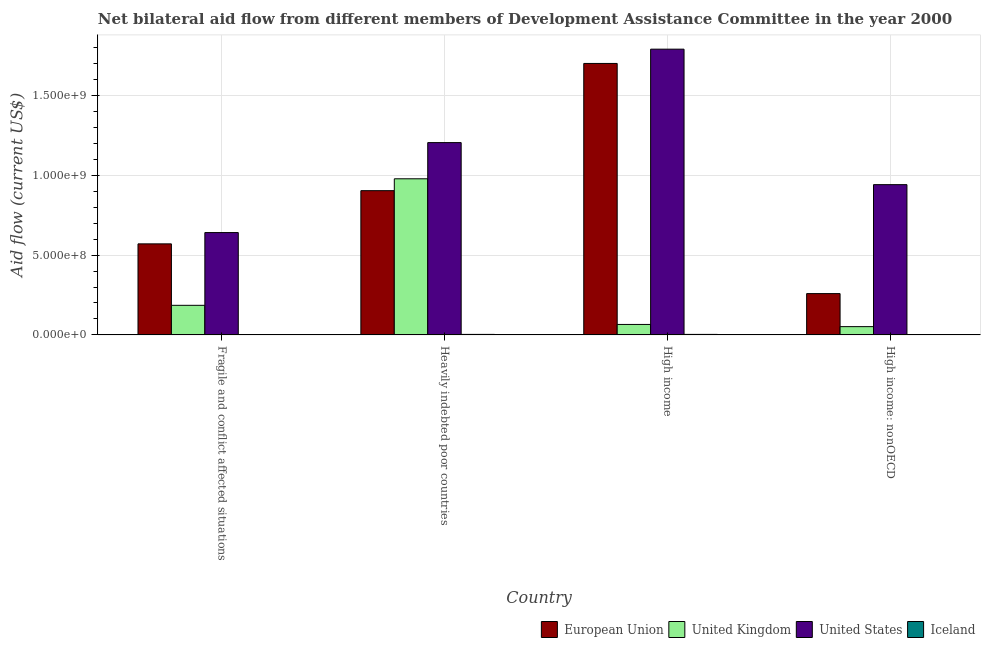How many different coloured bars are there?
Your answer should be compact. 4. Are the number of bars on each tick of the X-axis equal?
Your answer should be compact. Yes. How many bars are there on the 2nd tick from the right?
Make the answer very short. 4. What is the label of the 2nd group of bars from the left?
Make the answer very short. Heavily indebted poor countries. What is the amount of aid given by uk in Fragile and conflict affected situations?
Your answer should be very brief. 1.85e+08. Across all countries, what is the maximum amount of aid given by eu?
Offer a very short reply. 1.70e+09. Across all countries, what is the minimum amount of aid given by us?
Your answer should be very brief. 6.41e+08. In which country was the amount of aid given by us maximum?
Your answer should be compact. High income. In which country was the amount of aid given by iceland minimum?
Give a very brief answer. Fragile and conflict affected situations. What is the total amount of aid given by us in the graph?
Your answer should be very brief. 4.58e+09. What is the difference between the amount of aid given by us in Fragile and conflict affected situations and that in High income?
Keep it short and to the point. -1.15e+09. What is the difference between the amount of aid given by uk in Heavily indebted poor countries and the amount of aid given by us in Fragile and conflict affected situations?
Offer a terse response. 3.37e+08. What is the average amount of aid given by eu per country?
Provide a short and direct response. 8.59e+08. What is the difference between the amount of aid given by uk and amount of aid given by eu in Fragile and conflict affected situations?
Give a very brief answer. -3.85e+08. In how many countries, is the amount of aid given by eu greater than 1400000000 US$?
Offer a very short reply. 1. What is the ratio of the amount of aid given by uk in Fragile and conflict affected situations to that in High income: nonOECD?
Offer a terse response. 3.58. Is the difference between the amount of aid given by us in Fragile and conflict affected situations and Heavily indebted poor countries greater than the difference between the amount of aid given by eu in Fragile and conflict affected situations and Heavily indebted poor countries?
Provide a succinct answer. No. What is the difference between the highest and the second highest amount of aid given by eu?
Your response must be concise. 7.97e+08. What is the difference between the highest and the lowest amount of aid given by uk?
Your answer should be compact. 9.26e+08. In how many countries, is the amount of aid given by us greater than the average amount of aid given by us taken over all countries?
Provide a succinct answer. 2. Is the sum of the amount of aid given by iceland in Fragile and conflict affected situations and High income greater than the maximum amount of aid given by uk across all countries?
Provide a short and direct response. No. Is it the case that in every country, the sum of the amount of aid given by uk and amount of aid given by us is greater than the sum of amount of aid given by iceland and amount of aid given by eu?
Offer a very short reply. No. What does the 3rd bar from the right in High income: nonOECD represents?
Your answer should be very brief. United Kingdom. Is it the case that in every country, the sum of the amount of aid given by eu and amount of aid given by uk is greater than the amount of aid given by us?
Provide a short and direct response. No. How many bars are there?
Your answer should be very brief. 16. How many countries are there in the graph?
Make the answer very short. 4. Are the values on the major ticks of Y-axis written in scientific E-notation?
Offer a terse response. Yes. Does the graph contain any zero values?
Make the answer very short. No. Does the graph contain grids?
Your response must be concise. Yes. How many legend labels are there?
Your answer should be very brief. 4. What is the title of the graph?
Your answer should be compact. Net bilateral aid flow from different members of Development Assistance Committee in the year 2000. Does "Periodicity assessment" appear as one of the legend labels in the graph?
Your response must be concise. No. What is the label or title of the Y-axis?
Your answer should be very brief. Aid flow (current US$). What is the Aid flow (current US$) of European Union in Fragile and conflict affected situations?
Keep it short and to the point. 5.71e+08. What is the Aid flow (current US$) of United Kingdom in Fragile and conflict affected situations?
Provide a short and direct response. 1.85e+08. What is the Aid flow (current US$) of United States in Fragile and conflict affected situations?
Provide a succinct answer. 6.41e+08. What is the Aid flow (current US$) of Iceland in Fragile and conflict affected situations?
Offer a very short reply. 1.05e+06. What is the Aid flow (current US$) of European Union in Heavily indebted poor countries?
Your answer should be compact. 9.04e+08. What is the Aid flow (current US$) of United Kingdom in Heavily indebted poor countries?
Your answer should be very brief. 9.78e+08. What is the Aid flow (current US$) of United States in Heavily indebted poor countries?
Offer a very short reply. 1.21e+09. What is the Aid flow (current US$) in Iceland in Heavily indebted poor countries?
Give a very brief answer. 3.23e+06. What is the Aid flow (current US$) of European Union in High income?
Your response must be concise. 1.70e+09. What is the Aid flow (current US$) of United Kingdom in High income?
Ensure brevity in your answer.  6.56e+07. What is the Aid flow (current US$) in United States in High income?
Your answer should be compact. 1.79e+09. What is the Aid flow (current US$) in Iceland in High income?
Provide a short and direct response. 3.23e+06. What is the Aid flow (current US$) in European Union in High income: nonOECD?
Ensure brevity in your answer.  2.59e+08. What is the Aid flow (current US$) of United Kingdom in High income: nonOECD?
Your response must be concise. 5.18e+07. What is the Aid flow (current US$) of United States in High income: nonOECD?
Offer a very short reply. 9.42e+08. What is the Aid flow (current US$) in Iceland in High income: nonOECD?
Your answer should be very brief. 1.26e+06. Across all countries, what is the maximum Aid flow (current US$) in European Union?
Provide a short and direct response. 1.70e+09. Across all countries, what is the maximum Aid flow (current US$) of United Kingdom?
Offer a terse response. 9.78e+08. Across all countries, what is the maximum Aid flow (current US$) in United States?
Provide a short and direct response. 1.79e+09. Across all countries, what is the maximum Aid flow (current US$) of Iceland?
Ensure brevity in your answer.  3.23e+06. Across all countries, what is the minimum Aid flow (current US$) in European Union?
Offer a terse response. 2.59e+08. Across all countries, what is the minimum Aid flow (current US$) of United Kingdom?
Offer a terse response. 5.18e+07. Across all countries, what is the minimum Aid flow (current US$) of United States?
Offer a terse response. 6.41e+08. Across all countries, what is the minimum Aid flow (current US$) of Iceland?
Provide a succinct answer. 1.05e+06. What is the total Aid flow (current US$) of European Union in the graph?
Provide a succinct answer. 3.43e+09. What is the total Aid flow (current US$) of United Kingdom in the graph?
Offer a terse response. 1.28e+09. What is the total Aid flow (current US$) of United States in the graph?
Give a very brief answer. 4.58e+09. What is the total Aid flow (current US$) of Iceland in the graph?
Keep it short and to the point. 8.77e+06. What is the difference between the Aid flow (current US$) in European Union in Fragile and conflict affected situations and that in Heavily indebted poor countries?
Offer a very short reply. -3.33e+08. What is the difference between the Aid flow (current US$) in United Kingdom in Fragile and conflict affected situations and that in Heavily indebted poor countries?
Your answer should be very brief. -7.93e+08. What is the difference between the Aid flow (current US$) in United States in Fragile and conflict affected situations and that in Heavily indebted poor countries?
Provide a short and direct response. -5.64e+08. What is the difference between the Aid flow (current US$) in Iceland in Fragile and conflict affected situations and that in Heavily indebted poor countries?
Offer a terse response. -2.18e+06. What is the difference between the Aid flow (current US$) of European Union in Fragile and conflict affected situations and that in High income?
Give a very brief answer. -1.13e+09. What is the difference between the Aid flow (current US$) in United Kingdom in Fragile and conflict affected situations and that in High income?
Your answer should be very brief. 1.20e+08. What is the difference between the Aid flow (current US$) of United States in Fragile and conflict affected situations and that in High income?
Ensure brevity in your answer.  -1.15e+09. What is the difference between the Aid flow (current US$) of Iceland in Fragile and conflict affected situations and that in High income?
Provide a short and direct response. -2.18e+06. What is the difference between the Aid flow (current US$) of European Union in Fragile and conflict affected situations and that in High income: nonOECD?
Your answer should be very brief. 3.12e+08. What is the difference between the Aid flow (current US$) of United Kingdom in Fragile and conflict affected situations and that in High income: nonOECD?
Ensure brevity in your answer.  1.34e+08. What is the difference between the Aid flow (current US$) of United States in Fragile and conflict affected situations and that in High income: nonOECD?
Keep it short and to the point. -3.00e+08. What is the difference between the Aid flow (current US$) in European Union in Heavily indebted poor countries and that in High income?
Make the answer very short. -7.97e+08. What is the difference between the Aid flow (current US$) in United Kingdom in Heavily indebted poor countries and that in High income?
Provide a short and direct response. 9.13e+08. What is the difference between the Aid flow (current US$) of United States in Heavily indebted poor countries and that in High income?
Give a very brief answer. -5.86e+08. What is the difference between the Aid flow (current US$) of European Union in Heavily indebted poor countries and that in High income: nonOECD?
Give a very brief answer. 6.45e+08. What is the difference between the Aid flow (current US$) of United Kingdom in Heavily indebted poor countries and that in High income: nonOECD?
Ensure brevity in your answer.  9.26e+08. What is the difference between the Aid flow (current US$) of United States in Heavily indebted poor countries and that in High income: nonOECD?
Provide a short and direct response. 2.63e+08. What is the difference between the Aid flow (current US$) in Iceland in Heavily indebted poor countries and that in High income: nonOECD?
Keep it short and to the point. 1.97e+06. What is the difference between the Aid flow (current US$) in European Union in High income and that in High income: nonOECD?
Give a very brief answer. 1.44e+09. What is the difference between the Aid flow (current US$) of United Kingdom in High income and that in High income: nonOECD?
Your answer should be compact. 1.38e+07. What is the difference between the Aid flow (current US$) of United States in High income and that in High income: nonOECD?
Your answer should be compact. 8.49e+08. What is the difference between the Aid flow (current US$) in Iceland in High income and that in High income: nonOECD?
Offer a very short reply. 1.97e+06. What is the difference between the Aid flow (current US$) of European Union in Fragile and conflict affected situations and the Aid flow (current US$) of United Kingdom in Heavily indebted poor countries?
Ensure brevity in your answer.  -4.08e+08. What is the difference between the Aid flow (current US$) of European Union in Fragile and conflict affected situations and the Aid flow (current US$) of United States in Heavily indebted poor countries?
Ensure brevity in your answer.  -6.35e+08. What is the difference between the Aid flow (current US$) of European Union in Fragile and conflict affected situations and the Aid flow (current US$) of Iceland in Heavily indebted poor countries?
Provide a succinct answer. 5.67e+08. What is the difference between the Aid flow (current US$) in United Kingdom in Fragile and conflict affected situations and the Aid flow (current US$) in United States in Heavily indebted poor countries?
Provide a short and direct response. -1.02e+09. What is the difference between the Aid flow (current US$) in United Kingdom in Fragile and conflict affected situations and the Aid flow (current US$) in Iceland in Heavily indebted poor countries?
Make the answer very short. 1.82e+08. What is the difference between the Aid flow (current US$) in United States in Fragile and conflict affected situations and the Aid flow (current US$) in Iceland in Heavily indebted poor countries?
Provide a succinct answer. 6.38e+08. What is the difference between the Aid flow (current US$) of European Union in Fragile and conflict affected situations and the Aid flow (current US$) of United Kingdom in High income?
Provide a succinct answer. 5.05e+08. What is the difference between the Aid flow (current US$) of European Union in Fragile and conflict affected situations and the Aid flow (current US$) of United States in High income?
Keep it short and to the point. -1.22e+09. What is the difference between the Aid flow (current US$) in European Union in Fragile and conflict affected situations and the Aid flow (current US$) in Iceland in High income?
Give a very brief answer. 5.67e+08. What is the difference between the Aid flow (current US$) of United Kingdom in Fragile and conflict affected situations and the Aid flow (current US$) of United States in High income?
Your answer should be compact. -1.61e+09. What is the difference between the Aid flow (current US$) of United Kingdom in Fragile and conflict affected situations and the Aid flow (current US$) of Iceland in High income?
Provide a short and direct response. 1.82e+08. What is the difference between the Aid flow (current US$) in United States in Fragile and conflict affected situations and the Aid flow (current US$) in Iceland in High income?
Offer a terse response. 6.38e+08. What is the difference between the Aid flow (current US$) in European Union in Fragile and conflict affected situations and the Aid flow (current US$) in United Kingdom in High income: nonOECD?
Make the answer very short. 5.19e+08. What is the difference between the Aid flow (current US$) of European Union in Fragile and conflict affected situations and the Aid flow (current US$) of United States in High income: nonOECD?
Provide a succinct answer. -3.71e+08. What is the difference between the Aid flow (current US$) of European Union in Fragile and conflict affected situations and the Aid flow (current US$) of Iceland in High income: nonOECD?
Give a very brief answer. 5.69e+08. What is the difference between the Aid flow (current US$) in United Kingdom in Fragile and conflict affected situations and the Aid flow (current US$) in United States in High income: nonOECD?
Make the answer very short. -7.56e+08. What is the difference between the Aid flow (current US$) of United Kingdom in Fragile and conflict affected situations and the Aid flow (current US$) of Iceland in High income: nonOECD?
Provide a short and direct response. 1.84e+08. What is the difference between the Aid flow (current US$) of United States in Fragile and conflict affected situations and the Aid flow (current US$) of Iceland in High income: nonOECD?
Your answer should be compact. 6.40e+08. What is the difference between the Aid flow (current US$) in European Union in Heavily indebted poor countries and the Aid flow (current US$) in United Kingdom in High income?
Offer a terse response. 8.38e+08. What is the difference between the Aid flow (current US$) of European Union in Heavily indebted poor countries and the Aid flow (current US$) of United States in High income?
Provide a succinct answer. -8.87e+08. What is the difference between the Aid flow (current US$) in European Union in Heavily indebted poor countries and the Aid flow (current US$) in Iceland in High income?
Provide a succinct answer. 9.01e+08. What is the difference between the Aid flow (current US$) in United Kingdom in Heavily indebted poor countries and the Aid flow (current US$) in United States in High income?
Provide a succinct answer. -8.12e+08. What is the difference between the Aid flow (current US$) of United Kingdom in Heavily indebted poor countries and the Aid flow (current US$) of Iceland in High income?
Your answer should be compact. 9.75e+08. What is the difference between the Aid flow (current US$) of United States in Heavily indebted poor countries and the Aid flow (current US$) of Iceland in High income?
Give a very brief answer. 1.20e+09. What is the difference between the Aid flow (current US$) of European Union in Heavily indebted poor countries and the Aid flow (current US$) of United Kingdom in High income: nonOECD?
Make the answer very short. 8.52e+08. What is the difference between the Aid flow (current US$) of European Union in Heavily indebted poor countries and the Aid flow (current US$) of United States in High income: nonOECD?
Keep it short and to the point. -3.78e+07. What is the difference between the Aid flow (current US$) of European Union in Heavily indebted poor countries and the Aid flow (current US$) of Iceland in High income: nonOECD?
Your response must be concise. 9.03e+08. What is the difference between the Aid flow (current US$) in United Kingdom in Heavily indebted poor countries and the Aid flow (current US$) in United States in High income: nonOECD?
Provide a succinct answer. 3.67e+07. What is the difference between the Aid flow (current US$) in United Kingdom in Heavily indebted poor countries and the Aid flow (current US$) in Iceland in High income: nonOECD?
Your response must be concise. 9.77e+08. What is the difference between the Aid flow (current US$) of United States in Heavily indebted poor countries and the Aid flow (current US$) of Iceland in High income: nonOECD?
Keep it short and to the point. 1.20e+09. What is the difference between the Aid flow (current US$) of European Union in High income and the Aid flow (current US$) of United Kingdom in High income: nonOECD?
Provide a succinct answer. 1.65e+09. What is the difference between the Aid flow (current US$) of European Union in High income and the Aid flow (current US$) of United States in High income: nonOECD?
Offer a terse response. 7.59e+08. What is the difference between the Aid flow (current US$) in European Union in High income and the Aid flow (current US$) in Iceland in High income: nonOECD?
Your answer should be compact. 1.70e+09. What is the difference between the Aid flow (current US$) of United Kingdom in High income and the Aid flow (current US$) of United States in High income: nonOECD?
Offer a terse response. -8.76e+08. What is the difference between the Aid flow (current US$) of United Kingdom in High income and the Aid flow (current US$) of Iceland in High income: nonOECD?
Your response must be concise. 6.44e+07. What is the difference between the Aid flow (current US$) in United States in High income and the Aid flow (current US$) in Iceland in High income: nonOECD?
Keep it short and to the point. 1.79e+09. What is the average Aid flow (current US$) in European Union per country?
Your answer should be compact. 8.59e+08. What is the average Aid flow (current US$) in United Kingdom per country?
Provide a succinct answer. 3.20e+08. What is the average Aid flow (current US$) of United States per country?
Provide a short and direct response. 1.14e+09. What is the average Aid flow (current US$) of Iceland per country?
Ensure brevity in your answer.  2.19e+06. What is the difference between the Aid flow (current US$) of European Union and Aid flow (current US$) of United Kingdom in Fragile and conflict affected situations?
Provide a succinct answer. 3.85e+08. What is the difference between the Aid flow (current US$) in European Union and Aid flow (current US$) in United States in Fragile and conflict affected situations?
Offer a terse response. -7.07e+07. What is the difference between the Aid flow (current US$) in European Union and Aid flow (current US$) in Iceland in Fragile and conflict affected situations?
Offer a terse response. 5.70e+08. What is the difference between the Aid flow (current US$) in United Kingdom and Aid flow (current US$) in United States in Fragile and conflict affected situations?
Offer a very short reply. -4.56e+08. What is the difference between the Aid flow (current US$) of United Kingdom and Aid flow (current US$) of Iceland in Fragile and conflict affected situations?
Provide a short and direct response. 1.84e+08. What is the difference between the Aid flow (current US$) of United States and Aid flow (current US$) of Iceland in Fragile and conflict affected situations?
Ensure brevity in your answer.  6.40e+08. What is the difference between the Aid flow (current US$) in European Union and Aid flow (current US$) in United Kingdom in Heavily indebted poor countries?
Your response must be concise. -7.44e+07. What is the difference between the Aid flow (current US$) in European Union and Aid flow (current US$) in United States in Heavily indebted poor countries?
Your answer should be very brief. -3.01e+08. What is the difference between the Aid flow (current US$) of European Union and Aid flow (current US$) of Iceland in Heavily indebted poor countries?
Provide a short and direct response. 9.01e+08. What is the difference between the Aid flow (current US$) in United Kingdom and Aid flow (current US$) in United States in Heavily indebted poor countries?
Your answer should be compact. -2.27e+08. What is the difference between the Aid flow (current US$) in United Kingdom and Aid flow (current US$) in Iceland in Heavily indebted poor countries?
Give a very brief answer. 9.75e+08. What is the difference between the Aid flow (current US$) of United States and Aid flow (current US$) of Iceland in Heavily indebted poor countries?
Offer a very short reply. 1.20e+09. What is the difference between the Aid flow (current US$) of European Union and Aid flow (current US$) of United Kingdom in High income?
Your answer should be very brief. 1.64e+09. What is the difference between the Aid flow (current US$) of European Union and Aid flow (current US$) of United States in High income?
Provide a short and direct response. -8.96e+07. What is the difference between the Aid flow (current US$) in European Union and Aid flow (current US$) in Iceland in High income?
Ensure brevity in your answer.  1.70e+09. What is the difference between the Aid flow (current US$) of United Kingdom and Aid flow (current US$) of United States in High income?
Keep it short and to the point. -1.73e+09. What is the difference between the Aid flow (current US$) in United Kingdom and Aid flow (current US$) in Iceland in High income?
Your answer should be compact. 6.24e+07. What is the difference between the Aid flow (current US$) in United States and Aid flow (current US$) in Iceland in High income?
Make the answer very short. 1.79e+09. What is the difference between the Aid flow (current US$) in European Union and Aid flow (current US$) in United Kingdom in High income: nonOECD?
Make the answer very short. 2.07e+08. What is the difference between the Aid flow (current US$) in European Union and Aid flow (current US$) in United States in High income: nonOECD?
Your answer should be compact. -6.83e+08. What is the difference between the Aid flow (current US$) of European Union and Aid flow (current US$) of Iceland in High income: nonOECD?
Offer a very short reply. 2.58e+08. What is the difference between the Aid flow (current US$) of United Kingdom and Aid flow (current US$) of United States in High income: nonOECD?
Provide a succinct answer. -8.90e+08. What is the difference between the Aid flow (current US$) of United Kingdom and Aid flow (current US$) of Iceland in High income: nonOECD?
Make the answer very short. 5.06e+07. What is the difference between the Aid flow (current US$) of United States and Aid flow (current US$) of Iceland in High income: nonOECD?
Your answer should be very brief. 9.40e+08. What is the ratio of the Aid flow (current US$) of European Union in Fragile and conflict affected situations to that in Heavily indebted poor countries?
Give a very brief answer. 0.63. What is the ratio of the Aid flow (current US$) of United Kingdom in Fragile and conflict affected situations to that in Heavily indebted poor countries?
Keep it short and to the point. 0.19. What is the ratio of the Aid flow (current US$) of United States in Fragile and conflict affected situations to that in Heavily indebted poor countries?
Ensure brevity in your answer.  0.53. What is the ratio of the Aid flow (current US$) of Iceland in Fragile and conflict affected situations to that in Heavily indebted poor countries?
Ensure brevity in your answer.  0.33. What is the ratio of the Aid flow (current US$) in European Union in Fragile and conflict affected situations to that in High income?
Your answer should be compact. 0.34. What is the ratio of the Aid flow (current US$) in United Kingdom in Fragile and conflict affected situations to that in High income?
Provide a succinct answer. 2.83. What is the ratio of the Aid flow (current US$) in United States in Fragile and conflict affected situations to that in High income?
Offer a terse response. 0.36. What is the ratio of the Aid flow (current US$) of Iceland in Fragile and conflict affected situations to that in High income?
Your answer should be very brief. 0.33. What is the ratio of the Aid flow (current US$) of European Union in Fragile and conflict affected situations to that in High income: nonOECD?
Offer a very short reply. 2.2. What is the ratio of the Aid flow (current US$) in United Kingdom in Fragile and conflict affected situations to that in High income: nonOECD?
Make the answer very short. 3.58. What is the ratio of the Aid flow (current US$) of United States in Fragile and conflict affected situations to that in High income: nonOECD?
Give a very brief answer. 0.68. What is the ratio of the Aid flow (current US$) of Iceland in Fragile and conflict affected situations to that in High income: nonOECD?
Ensure brevity in your answer.  0.83. What is the ratio of the Aid flow (current US$) in European Union in Heavily indebted poor countries to that in High income?
Keep it short and to the point. 0.53. What is the ratio of the Aid flow (current US$) in United Kingdom in Heavily indebted poor countries to that in High income?
Keep it short and to the point. 14.91. What is the ratio of the Aid flow (current US$) in United States in Heavily indebted poor countries to that in High income?
Offer a terse response. 0.67. What is the ratio of the Aid flow (current US$) in Iceland in Heavily indebted poor countries to that in High income?
Provide a succinct answer. 1. What is the ratio of the Aid flow (current US$) in European Union in Heavily indebted poor countries to that in High income: nonOECD?
Offer a terse response. 3.49. What is the ratio of the Aid flow (current US$) in United Kingdom in Heavily indebted poor countries to that in High income: nonOECD?
Keep it short and to the point. 18.87. What is the ratio of the Aid flow (current US$) in United States in Heavily indebted poor countries to that in High income: nonOECD?
Ensure brevity in your answer.  1.28. What is the ratio of the Aid flow (current US$) of Iceland in Heavily indebted poor countries to that in High income: nonOECD?
Your answer should be very brief. 2.56. What is the ratio of the Aid flow (current US$) in European Union in High income to that in High income: nonOECD?
Keep it short and to the point. 6.57. What is the ratio of the Aid flow (current US$) in United Kingdom in High income to that in High income: nonOECD?
Your answer should be compact. 1.27. What is the ratio of the Aid flow (current US$) of United States in High income to that in High income: nonOECD?
Your response must be concise. 1.9. What is the ratio of the Aid flow (current US$) of Iceland in High income to that in High income: nonOECD?
Provide a short and direct response. 2.56. What is the difference between the highest and the second highest Aid flow (current US$) of European Union?
Give a very brief answer. 7.97e+08. What is the difference between the highest and the second highest Aid flow (current US$) in United Kingdom?
Make the answer very short. 7.93e+08. What is the difference between the highest and the second highest Aid flow (current US$) of United States?
Offer a terse response. 5.86e+08. What is the difference between the highest and the second highest Aid flow (current US$) of Iceland?
Provide a succinct answer. 0. What is the difference between the highest and the lowest Aid flow (current US$) in European Union?
Provide a succinct answer. 1.44e+09. What is the difference between the highest and the lowest Aid flow (current US$) in United Kingdom?
Give a very brief answer. 9.26e+08. What is the difference between the highest and the lowest Aid flow (current US$) in United States?
Give a very brief answer. 1.15e+09. What is the difference between the highest and the lowest Aid flow (current US$) of Iceland?
Make the answer very short. 2.18e+06. 